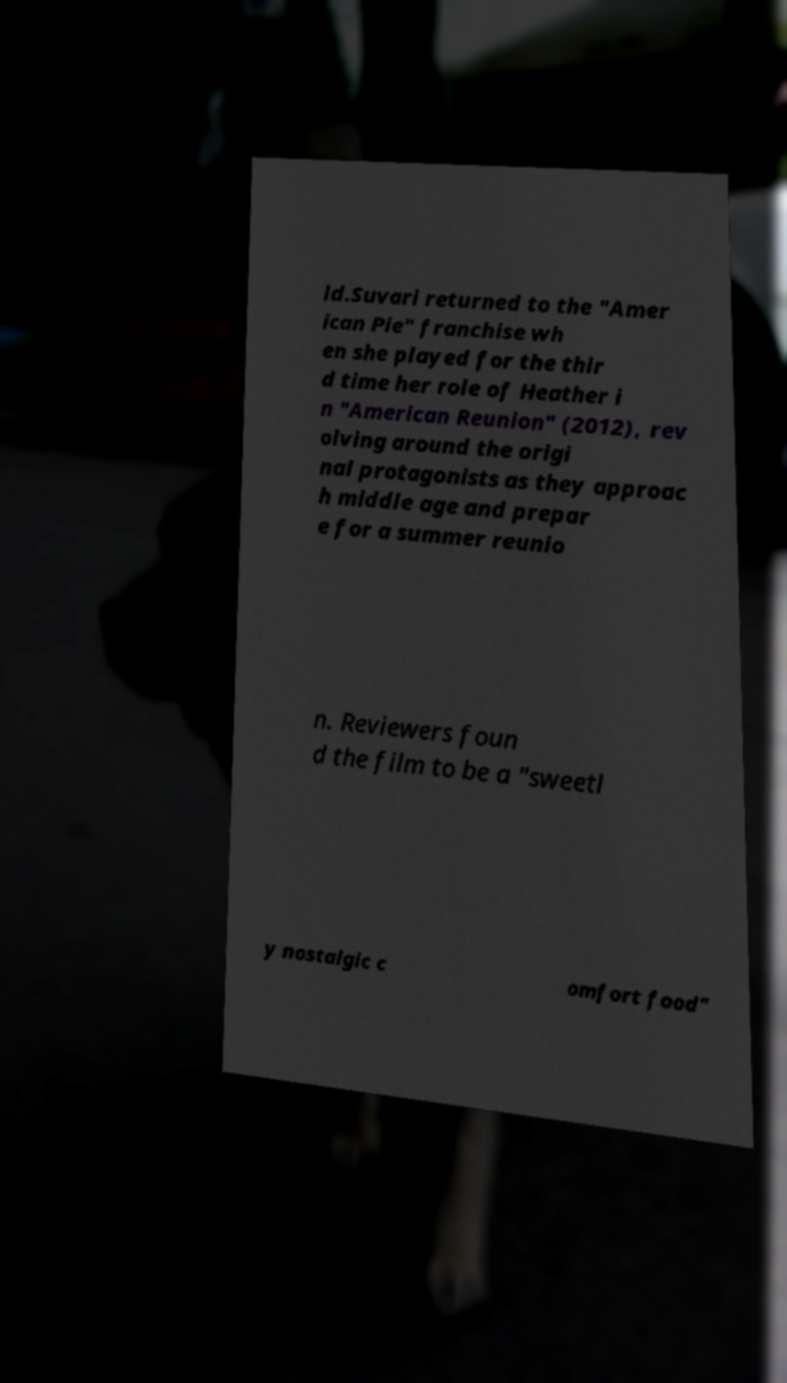Could you extract and type out the text from this image? ld.Suvari returned to the "Amer ican Pie" franchise wh en she played for the thir d time her role of Heather i n "American Reunion" (2012), rev olving around the origi nal protagonists as they approac h middle age and prepar e for a summer reunio n. Reviewers foun d the film to be a "sweetl y nostalgic c omfort food" 